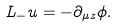Convert formula to latex. <formula><loc_0><loc_0><loc_500><loc_500>L _ { - } u = - \partial _ { \mu z } \phi .</formula> 